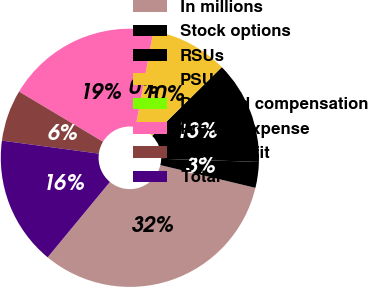Convert chart. <chart><loc_0><loc_0><loc_500><loc_500><pie_chart><fcel>In millions<fcel>Stock options<fcel>RSUs<fcel>PSUs<fcel>Deferred compensation<fcel>Pre-tax expense<fcel>Tax benefit<fcel>Total<nl><fcel>32.25%<fcel>3.23%<fcel>12.9%<fcel>9.68%<fcel>0.0%<fcel>19.35%<fcel>6.45%<fcel>16.13%<nl></chart> 